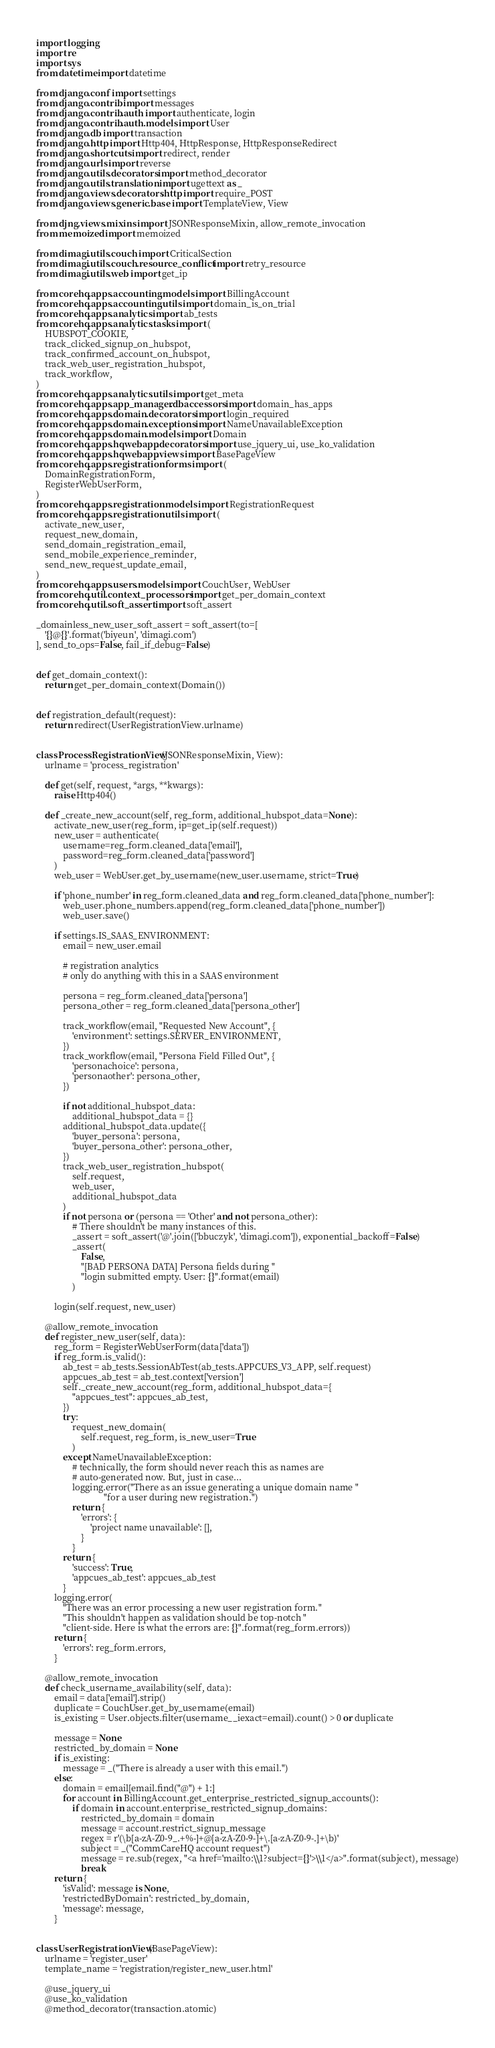Convert code to text. <code><loc_0><loc_0><loc_500><loc_500><_Python_>import logging
import re
import sys
from datetime import datetime

from django.conf import settings
from django.contrib import messages
from django.contrib.auth import authenticate, login
from django.contrib.auth.models import User
from django.db import transaction
from django.http import Http404, HttpResponse, HttpResponseRedirect
from django.shortcuts import redirect, render
from django.urls import reverse
from django.utils.decorators import method_decorator
from django.utils.translation import ugettext as _
from django.views.decorators.http import require_POST
from django.views.generic.base import TemplateView, View

from djng.views.mixins import JSONResponseMixin, allow_remote_invocation
from memoized import memoized

from dimagi.utils.couch import CriticalSection
from dimagi.utils.couch.resource_conflict import retry_resource
from dimagi.utils.web import get_ip

from corehq.apps.accounting.models import BillingAccount
from corehq.apps.accounting.utils import domain_is_on_trial
from corehq.apps.analytics import ab_tests
from corehq.apps.analytics.tasks import (
    HUBSPOT_COOKIE,
    track_clicked_signup_on_hubspot,
    track_confirmed_account_on_hubspot,
    track_web_user_registration_hubspot,
    track_workflow,
)
from corehq.apps.analytics.utils import get_meta
from corehq.apps.app_manager.dbaccessors import domain_has_apps
from corehq.apps.domain.decorators import login_required
from corehq.apps.domain.exceptions import NameUnavailableException
from corehq.apps.domain.models import Domain
from corehq.apps.hqwebapp.decorators import use_jquery_ui, use_ko_validation
from corehq.apps.hqwebapp.views import BasePageView
from corehq.apps.registration.forms import (
    DomainRegistrationForm,
    RegisterWebUserForm,
)
from corehq.apps.registration.models import RegistrationRequest
from corehq.apps.registration.utils import (
    activate_new_user,
    request_new_domain,
    send_domain_registration_email,
    send_mobile_experience_reminder,
    send_new_request_update_email,
)
from corehq.apps.users.models import CouchUser, WebUser
from corehq.util.context_processors import get_per_domain_context
from corehq.util.soft_assert import soft_assert

_domainless_new_user_soft_assert = soft_assert(to=[
    '{}@{}'.format('biyeun', 'dimagi.com')
], send_to_ops=False, fail_if_debug=False)


def get_domain_context():
    return get_per_domain_context(Domain())


def registration_default(request):
    return redirect(UserRegistrationView.urlname)


class ProcessRegistrationView(JSONResponseMixin, View):
    urlname = 'process_registration'

    def get(self, request, *args, **kwargs):
        raise Http404()

    def _create_new_account(self, reg_form, additional_hubspot_data=None):
        activate_new_user(reg_form, ip=get_ip(self.request))
        new_user = authenticate(
            username=reg_form.cleaned_data['email'],
            password=reg_form.cleaned_data['password']
        )
        web_user = WebUser.get_by_username(new_user.username, strict=True)

        if 'phone_number' in reg_form.cleaned_data and reg_form.cleaned_data['phone_number']:
            web_user.phone_numbers.append(reg_form.cleaned_data['phone_number'])
            web_user.save()

        if settings.IS_SAAS_ENVIRONMENT:
            email = new_user.email

            # registration analytics
            # only do anything with this in a SAAS environment

            persona = reg_form.cleaned_data['persona']
            persona_other = reg_form.cleaned_data['persona_other']

            track_workflow(email, "Requested New Account", {
                'environment': settings.SERVER_ENVIRONMENT,
            })
            track_workflow(email, "Persona Field Filled Out", {
                'personachoice': persona,
                'personaother': persona_other,
            })

            if not additional_hubspot_data:
                additional_hubspot_data = {}
            additional_hubspot_data.update({
                'buyer_persona': persona,
                'buyer_persona_other': persona_other,
            })
            track_web_user_registration_hubspot(
                self.request,
                web_user,
                additional_hubspot_data
            )
            if not persona or (persona == 'Other' and not persona_other):
                # There shouldn't be many instances of this.
                _assert = soft_assert('@'.join(['bbuczyk', 'dimagi.com']), exponential_backoff=False)
                _assert(
                    False,
                    "[BAD PERSONA DATA] Persona fields during "
                    "login submitted empty. User: {}".format(email)
                )

        login(self.request, new_user)

    @allow_remote_invocation
    def register_new_user(self, data):
        reg_form = RegisterWebUserForm(data['data'])
        if reg_form.is_valid():
            ab_test = ab_tests.SessionAbTest(ab_tests.APPCUES_V3_APP, self.request)
            appcues_ab_test = ab_test.context['version']
            self._create_new_account(reg_form, additional_hubspot_data={
                "appcues_test": appcues_ab_test,
            })
            try:
                request_new_domain(
                    self.request, reg_form, is_new_user=True
                )
            except NameUnavailableException:
                # technically, the form should never reach this as names are
                # auto-generated now. But, just in case...
                logging.error("There as an issue generating a unique domain name "
                              "for a user during new registration.")
                return {
                    'errors': {
                        'project name unavailable': [],
                    }
                }
            return {
                'success': True,
                'appcues_ab_test': appcues_ab_test
            }
        logging.error(
            "There was an error processing a new user registration form."
            "This shouldn't happen as validation should be top-notch "
            "client-side. Here is what the errors are: {}".format(reg_form.errors))
        return {
            'errors': reg_form.errors,
        }

    @allow_remote_invocation
    def check_username_availability(self, data):
        email = data['email'].strip()
        duplicate = CouchUser.get_by_username(email)
        is_existing = User.objects.filter(username__iexact=email).count() > 0 or duplicate

        message = None
        restricted_by_domain = None
        if is_existing:
            message = _("There is already a user with this email.")
        else:
            domain = email[email.find("@") + 1:]
            for account in BillingAccount.get_enterprise_restricted_signup_accounts():
                if domain in account.enterprise_restricted_signup_domains:
                    restricted_by_domain = domain
                    message = account.restrict_signup_message
                    regex = r'(\b[a-zA-Z0-9_.+%-]+@[a-zA-Z0-9-]+\.[a-zA-Z0-9-.]+\b)'
                    subject = _("CommCareHQ account request")
                    message = re.sub(regex, "<a href='mailto:\\1?subject={}'>\\1</a>".format(subject), message)
                    break
        return {
            'isValid': message is None,
            'restrictedByDomain': restricted_by_domain,
            'message': message,
        }


class UserRegistrationView(BasePageView):
    urlname = 'register_user'
    template_name = 'registration/register_new_user.html'

    @use_jquery_ui
    @use_ko_validation
    @method_decorator(transaction.atomic)</code> 